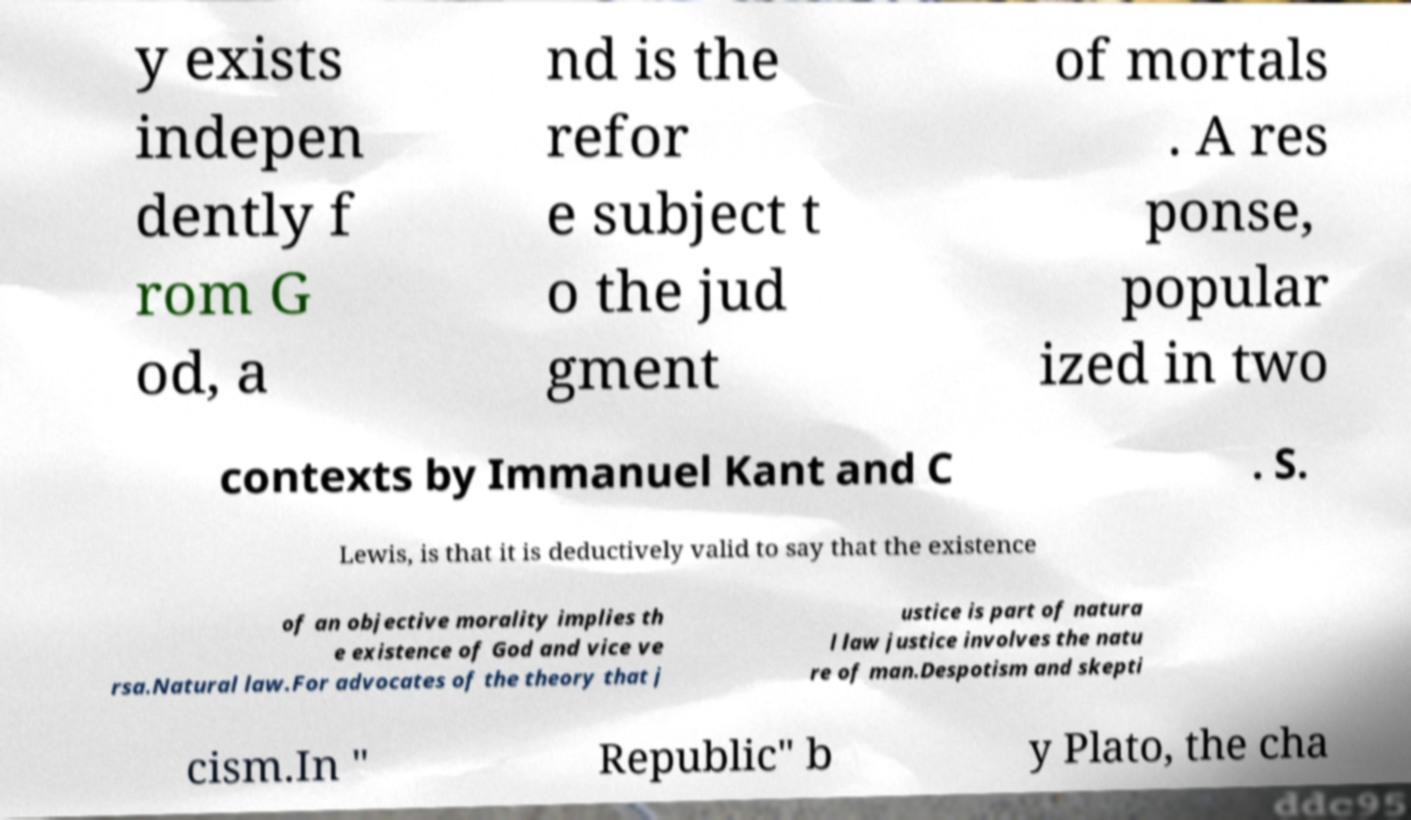There's text embedded in this image that I need extracted. Can you transcribe it verbatim? y exists indepen dently f rom G od, a nd is the refor e subject t o the jud gment of mortals . A res ponse, popular ized in two contexts by Immanuel Kant and C . S. Lewis, is that it is deductively valid to say that the existence of an objective morality implies th e existence of God and vice ve rsa.Natural law.For advocates of the theory that j ustice is part of natura l law justice involves the natu re of man.Despotism and skepti cism.In " Republic" b y Plato, the cha 